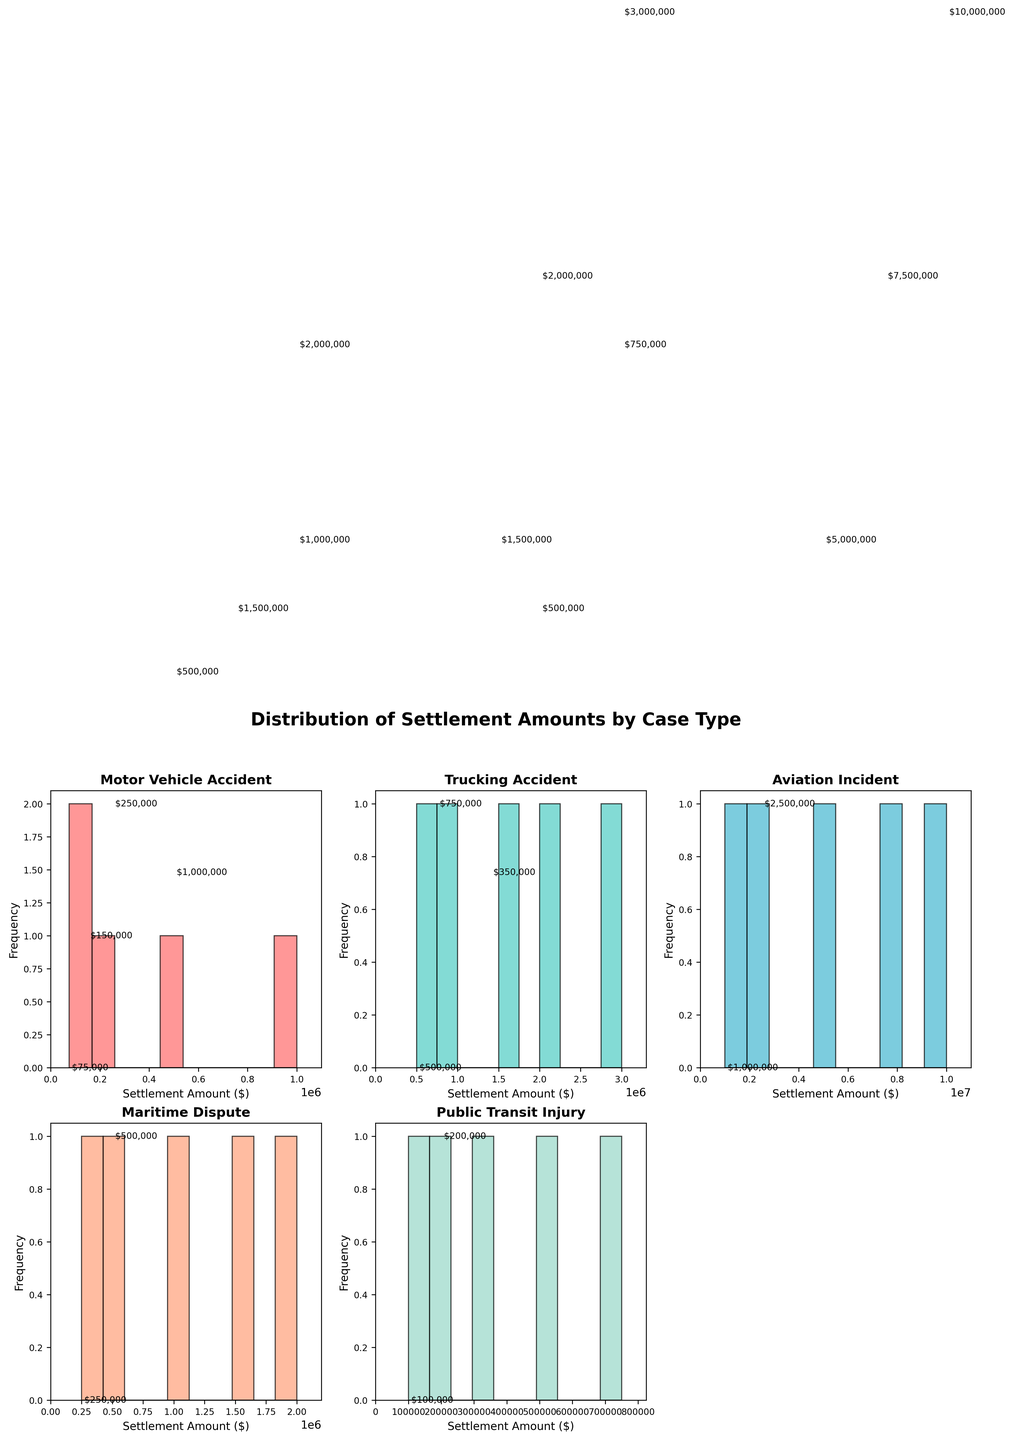How many case types are presented in the subplots? Inspect all subplots' titles. Each subplot represents a different case type and accounts for five distinct case types.
Answer: 5 Which case type has the highest maximum settlement amount? Look at the x-axis limit (maximum value) among all the subplots. The Aviation Incident subplot extends to the highest value at $10,000,000.
Answer: Aviation Incident What is the most frequent settlement amount for motor vehicle accidents? For the Motor Vehicle Accident subplot, identify the bin with the most occurrences. The $1,000,000 settlement amount appears to be the most frequent.
Answer: $1,000,000 How do the settlement amounts for trucking accidents compare to maritime disputes in terms of range? Compare the maximum values on the x-axes of both subplots. Trucking accidents range up to $3,000,000, and maritime disputes up to $2,000,000.
Answer: Trucking Accidents have a higher range Which case type has the smallest bin frequency? Observe each subplot for the bin with the least counts. Public Transit Injury shows the least frequent bin with fewer bars reaching higher frequencies.
Answer: Public Transit Injury What is the average settlement amount for public transit injury cases? Sum all settlement amounts for Public Transit Injury cases and divide by the number of cases: (100000 + 200000 + 350000 + 500000 + 750000) / 5 = $1,900,000/5.
Answer: $380,000 How do settlement patterns in motor vehicle accidents differ from aviation incidents? Compare the shape and spread of the histograms. Motor Vehicle Accidents have a more uniform distribution, while Aviation Incidents display a broader spread up to $10,000,000.
Answer: More uniform vs. broader spread Which two case types have no settlement amounts exceeding $2,000,000? Inspect the x-axes of all subplots. No bars extend past $2,000,000 for both Maritime Dispute and Public Transit Injury.
Answer: Maritime Dispute and Public Transit Injury Is the frequency of settlements over $5,000,000 higher in aviation incidents compared to trucking accidents? Check the number of bins with values over $5,000,000. Aviation Incidents have more bins and bars, indicating higher frequency compared to Trucking Accidents.
Answer: Yes What is the combined maximum value for the Motor Vehicle Accident and Public Transit Injury subplots? Identify the maximum values from both subplots and sum them: $1,000,000 (Motor Vehicle Accident) + $750,000 (Public Transit Injury) = $1,750,000.
Answer: $1,750,000 